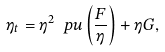Convert formula to latex. <formula><loc_0><loc_0><loc_500><loc_500>\eta _ { t } = \eta ^ { 2 } \ p u \left ( \frac { F } { \eta } \right ) + \eta G ,</formula> 